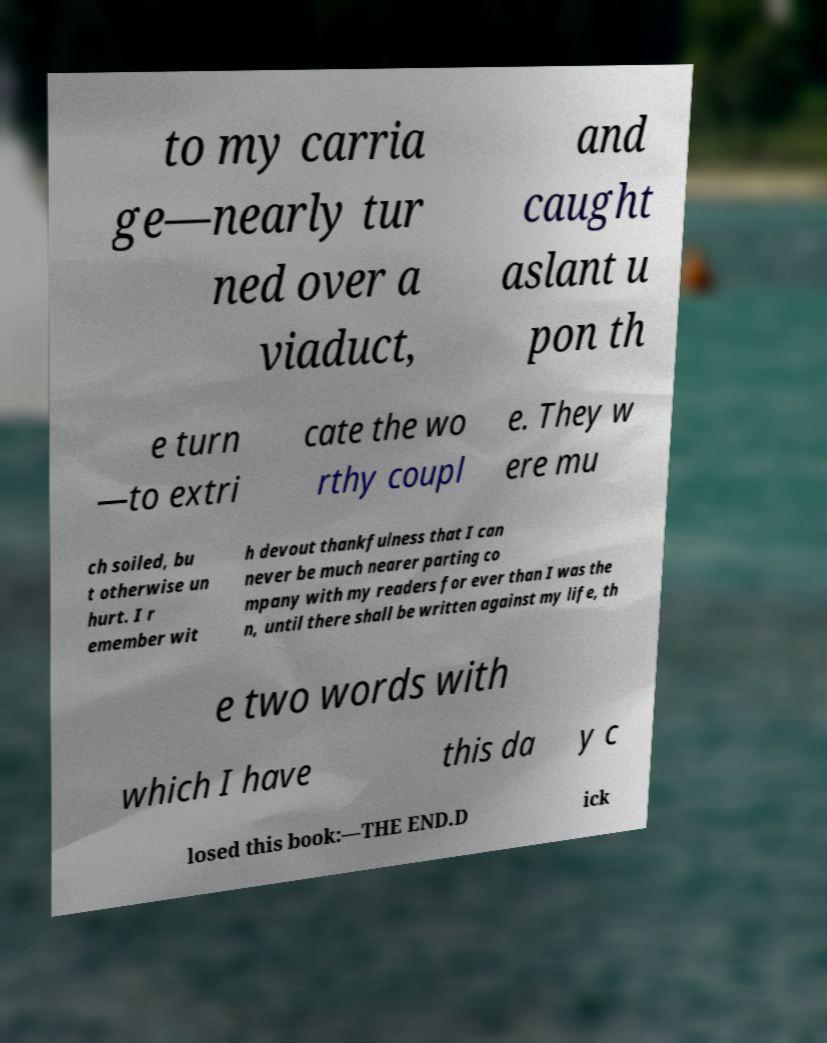Can you read and provide the text displayed in the image?This photo seems to have some interesting text. Can you extract and type it out for me? to my carria ge—nearly tur ned over a viaduct, and caught aslant u pon th e turn —to extri cate the wo rthy coupl e. They w ere mu ch soiled, bu t otherwise un hurt. I r emember wit h devout thankfulness that I can never be much nearer parting co mpany with my readers for ever than I was the n, until there shall be written against my life, th e two words with which I have this da y c losed this book:—THE END.D ick 